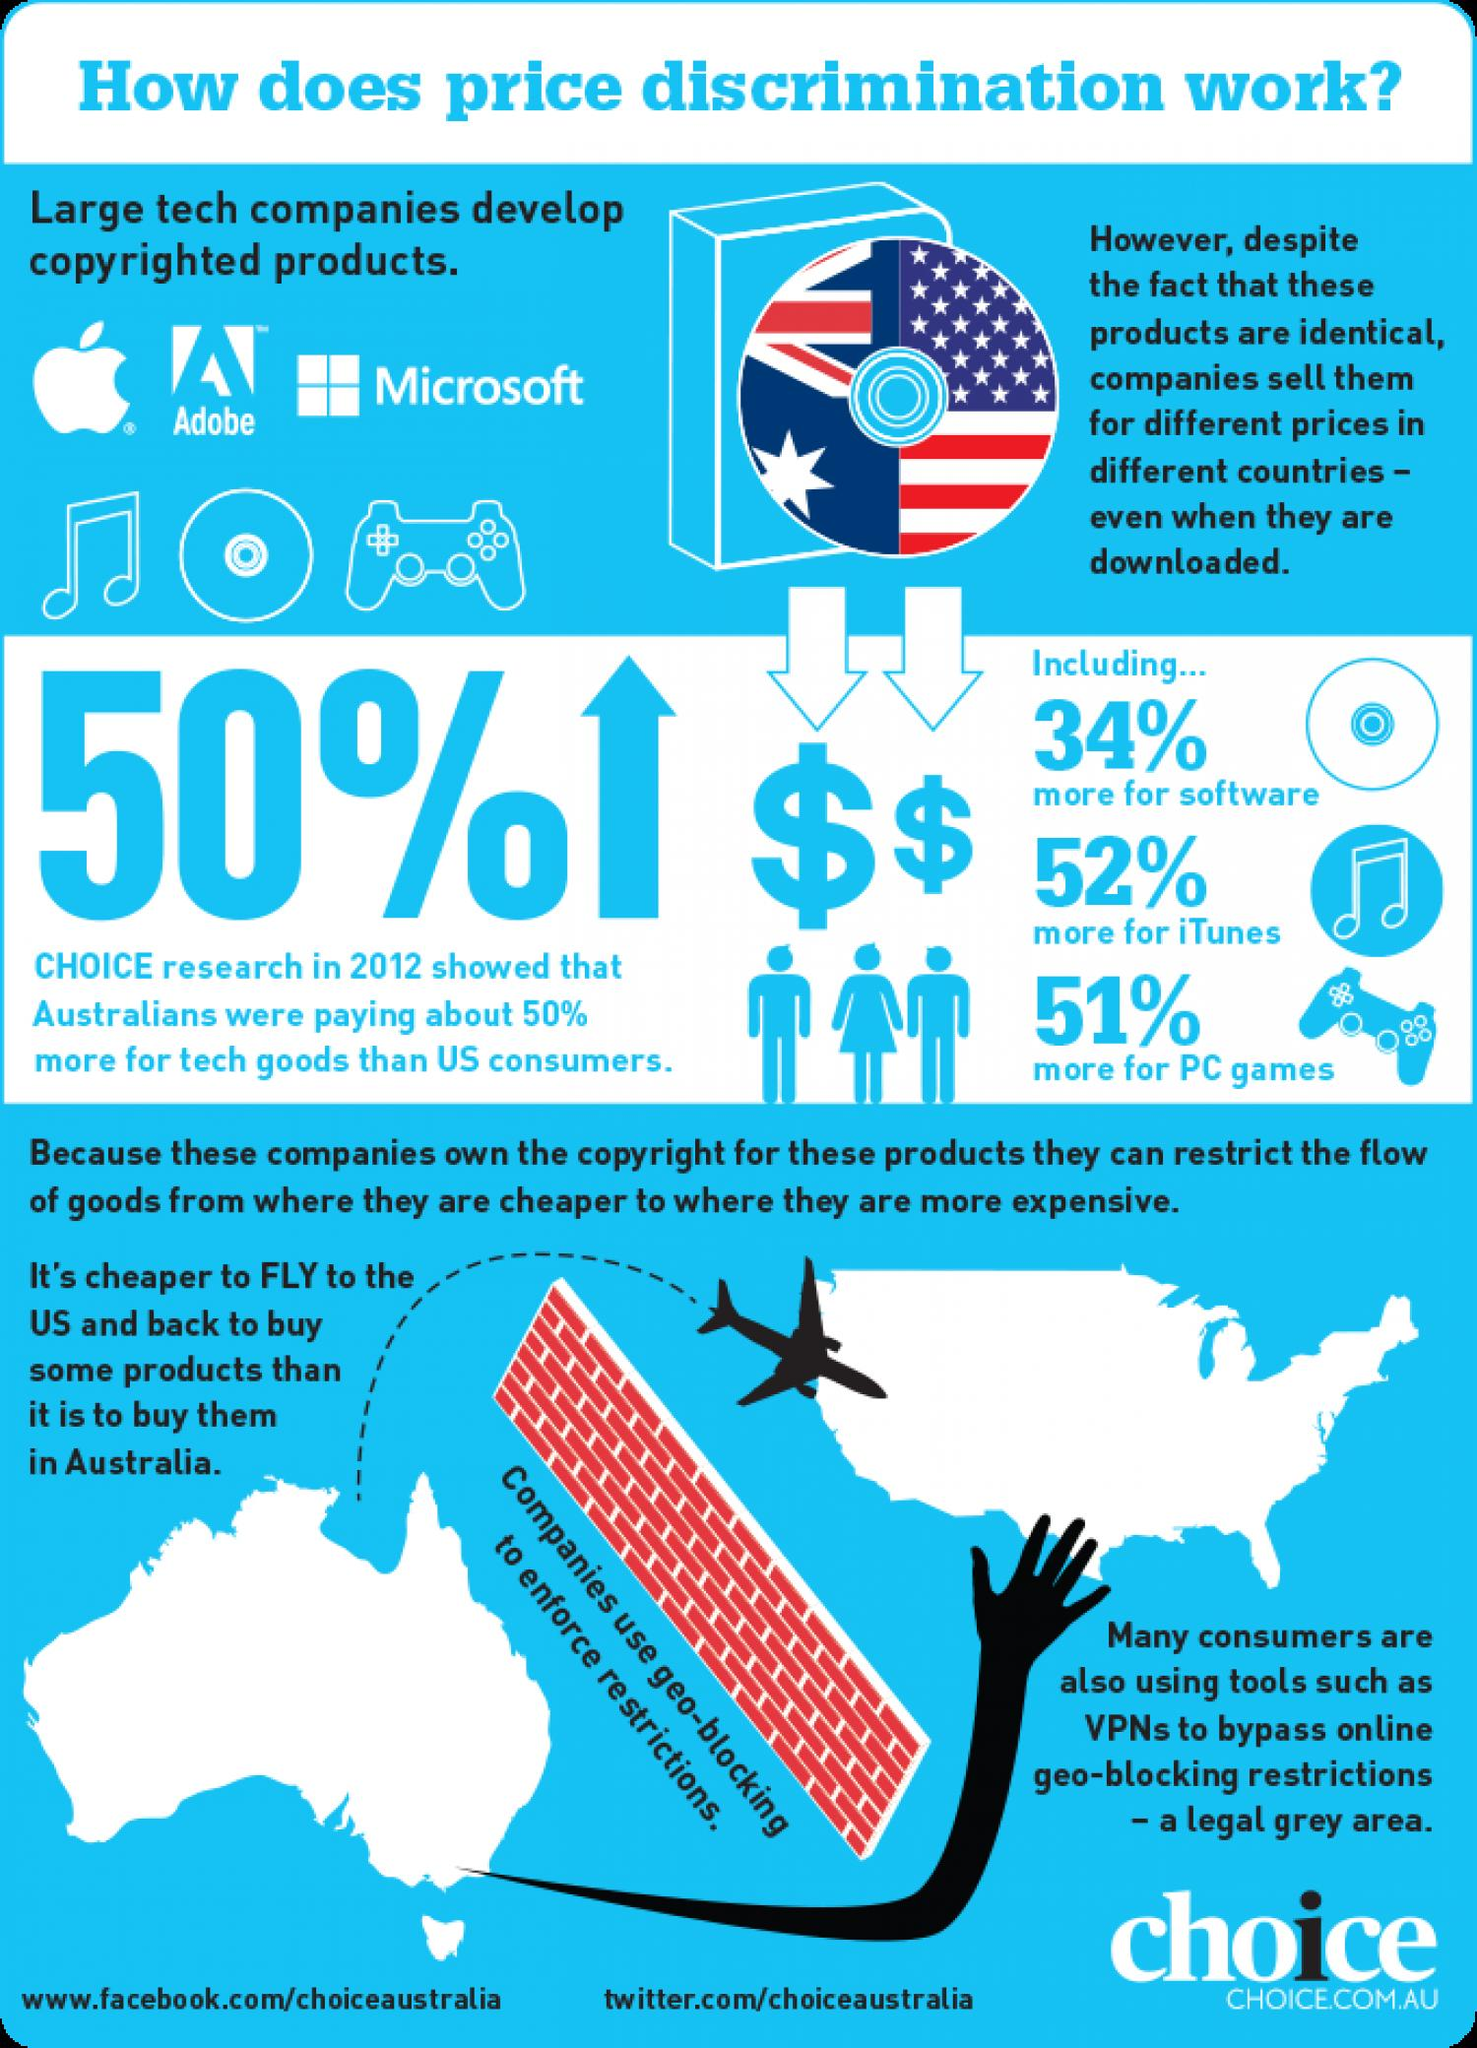Point out several critical features in this image. Geo-blocking is a technique used to enforce restrictions. 